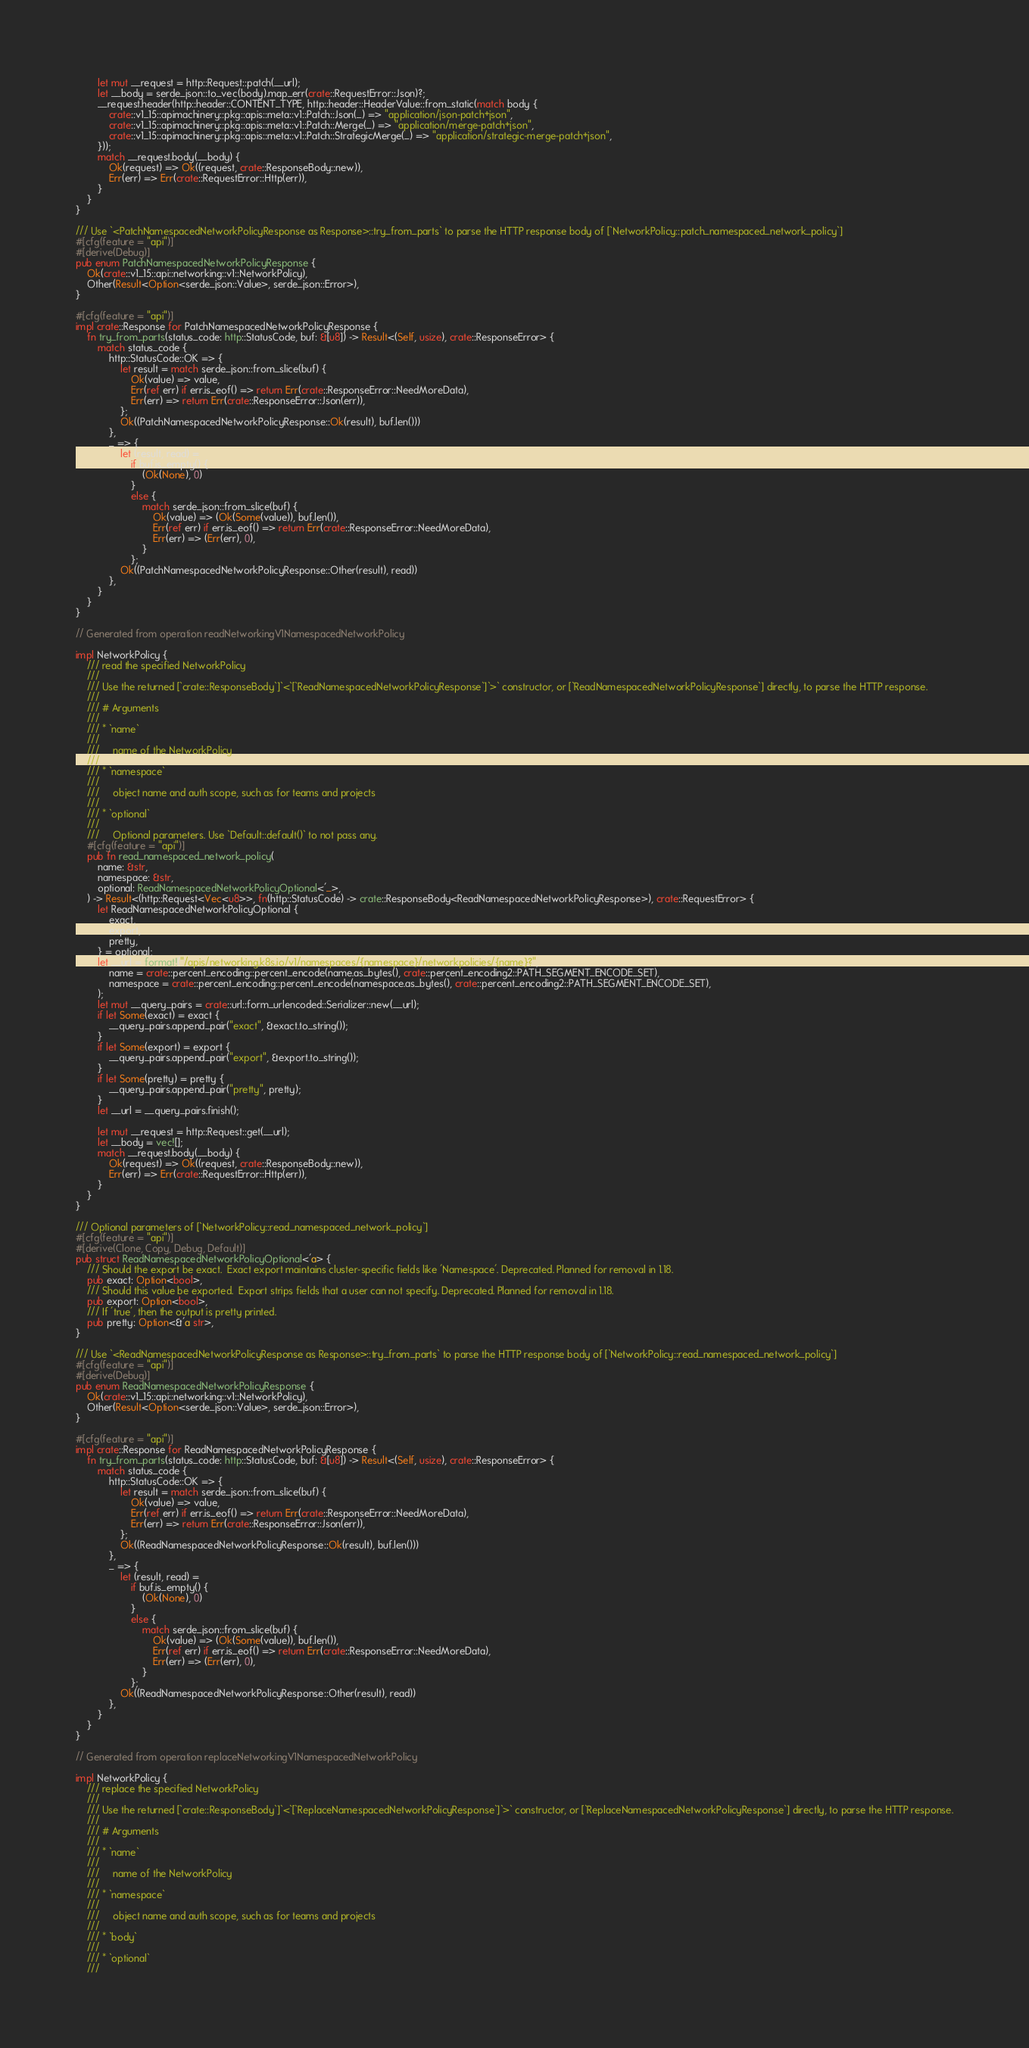Convert code to text. <code><loc_0><loc_0><loc_500><loc_500><_Rust_>        let mut __request = http::Request::patch(__url);
        let __body = serde_json::to_vec(body).map_err(crate::RequestError::Json)?;
        __request.header(http::header::CONTENT_TYPE, http::header::HeaderValue::from_static(match body {
            crate::v1_15::apimachinery::pkg::apis::meta::v1::Patch::Json(_) => "application/json-patch+json",
            crate::v1_15::apimachinery::pkg::apis::meta::v1::Patch::Merge(_) => "application/merge-patch+json",
            crate::v1_15::apimachinery::pkg::apis::meta::v1::Patch::StrategicMerge(_) => "application/strategic-merge-patch+json",
        }));
        match __request.body(__body) {
            Ok(request) => Ok((request, crate::ResponseBody::new)),
            Err(err) => Err(crate::RequestError::Http(err)),
        }
    }
}

/// Use `<PatchNamespacedNetworkPolicyResponse as Response>::try_from_parts` to parse the HTTP response body of [`NetworkPolicy::patch_namespaced_network_policy`]
#[cfg(feature = "api")]
#[derive(Debug)]
pub enum PatchNamespacedNetworkPolicyResponse {
    Ok(crate::v1_15::api::networking::v1::NetworkPolicy),
    Other(Result<Option<serde_json::Value>, serde_json::Error>),
}

#[cfg(feature = "api")]
impl crate::Response for PatchNamespacedNetworkPolicyResponse {
    fn try_from_parts(status_code: http::StatusCode, buf: &[u8]) -> Result<(Self, usize), crate::ResponseError> {
        match status_code {
            http::StatusCode::OK => {
                let result = match serde_json::from_slice(buf) {
                    Ok(value) => value,
                    Err(ref err) if err.is_eof() => return Err(crate::ResponseError::NeedMoreData),
                    Err(err) => return Err(crate::ResponseError::Json(err)),
                };
                Ok((PatchNamespacedNetworkPolicyResponse::Ok(result), buf.len()))
            },
            _ => {
                let (result, read) =
                    if buf.is_empty() {
                        (Ok(None), 0)
                    }
                    else {
                        match serde_json::from_slice(buf) {
                            Ok(value) => (Ok(Some(value)), buf.len()),
                            Err(ref err) if err.is_eof() => return Err(crate::ResponseError::NeedMoreData),
                            Err(err) => (Err(err), 0),
                        }
                    };
                Ok((PatchNamespacedNetworkPolicyResponse::Other(result), read))
            },
        }
    }
}

// Generated from operation readNetworkingV1NamespacedNetworkPolicy

impl NetworkPolicy {
    /// read the specified NetworkPolicy
    ///
    /// Use the returned [`crate::ResponseBody`]`<`[`ReadNamespacedNetworkPolicyResponse`]`>` constructor, or [`ReadNamespacedNetworkPolicyResponse`] directly, to parse the HTTP response.
    ///
    /// # Arguments
    ///
    /// * `name`
    ///
    ///     name of the NetworkPolicy
    ///
    /// * `namespace`
    ///
    ///     object name and auth scope, such as for teams and projects
    ///
    /// * `optional`
    ///
    ///     Optional parameters. Use `Default::default()` to not pass any.
    #[cfg(feature = "api")]
    pub fn read_namespaced_network_policy(
        name: &str,
        namespace: &str,
        optional: ReadNamespacedNetworkPolicyOptional<'_>,
    ) -> Result<(http::Request<Vec<u8>>, fn(http::StatusCode) -> crate::ResponseBody<ReadNamespacedNetworkPolicyResponse>), crate::RequestError> {
        let ReadNamespacedNetworkPolicyOptional {
            exact,
            export,
            pretty,
        } = optional;
        let __url = format!("/apis/networking.k8s.io/v1/namespaces/{namespace}/networkpolicies/{name}?",
            name = crate::percent_encoding::percent_encode(name.as_bytes(), crate::percent_encoding2::PATH_SEGMENT_ENCODE_SET),
            namespace = crate::percent_encoding::percent_encode(namespace.as_bytes(), crate::percent_encoding2::PATH_SEGMENT_ENCODE_SET),
        );
        let mut __query_pairs = crate::url::form_urlencoded::Serializer::new(__url);
        if let Some(exact) = exact {
            __query_pairs.append_pair("exact", &exact.to_string());
        }
        if let Some(export) = export {
            __query_pairs.append_pair("export", &export.to_string());
        }
        if let Some(pretty) = pretty {
            __query_pairs.append_pair("pretty", pretty);
        }
        let __url = __query_pairs.finish();

        let mut __request = http::Request::get(__url);
        let __body = vec![];
        match __request.body(__body) {
            Ok(request) => Ok((request, crate::ResponseBody::new)),
            Err(err) => Err(crate::RequestError::Http(err)),
        }
    }
}

/// Optional parameters of [`NetworkPolicy::read_namespaced_network_policy`]
#[cfg(feature = "api")]
#[derive(Clone, Copy, Debug, Default)]
pub struct ReadNamespacedNetworkPolicyOptional<'a> {
    /// Should the export be exact.  Exact export maintains cluster-specific fields like 'Namespace'. Deprecated. Planned for removal in 1.18.
    pub exact: Option<bool>,
    /// Should this value be exported.  Export strips fields that a user can not specify. Deprecated. Planned for removal in 1.18.
    pub export: Option<bool>,
    /// If 'true', then the output is pretty printed.
    pub pretty: Option<&'a str>,
}

/// Use `<ReadNamespacedNetworkPolicyResponse as Response>::try_from_parts` to parse the HTTP response body of [`NetworkPolicy::read_namespaced_network_policy`]
#[cfg(feature = "api")]
#[derive(Debug)]
pub enum ReadNamespacedNetworkPolicyResponse {
    Ok(crate::v1_15::api::networking::v1::NetworkPolicy),
    Other(Result<Option<serde_json::Value>, serde_json::Error>),
}

#[cfg(feature = "api")]
impl crate::Response for ReadNamespacedNetworkPolicyResponse {
    fn try_from_parts(status_code: http::StatusCode, buf: &[u8]) -> Result<(Self, usize), crate::ResponseError> {
        match status_code {
            http::StatusCode::OK => {
                let result = match serde_json::from_slice(buf) {
                    Ok(value) => value,
                    Err(ref err) if err.is_eof() => return Err(crate::ResponseError::NeedMoreData),
                    Err(err) => return Err(crate::ResponseError::Json(err)),
                };
                Ok((ReadNamespacedNetworkPolicyResponse::Ok(result), buf.len()))
            },
            _ => {
                let (result, read) =
                    if buf.is_empty() {
                        (Ok(None), 0)
                    }
                    else {
                        match serde_json::from_slice(buf) {
                            Ok(value) => (Ok(Some(value)), buf.len()),
                            Err(ref err) if err.is_eof() => return Err(crate::ResponseError::NeedMoreData),
                            Err(err) => (Err(err), 0),
                        }
                    };
                Ok((ReadNamespacedNetworkPolicyResponse::Other(result), read))
            },
        }
    }
}

// Generated from operation replaceNetworkingV1NamespacedNetworkPolicy

impl NetworkPolicy {
    /// replace the specified NetworkPolicy
    ///
    /// Use the returned [`crate::ResponseBody`]`<`[`ReplaceNamespacedNetworkPolicyResponse`]`>` constructor, or [`ReplaceNamespacedNetworkPolicyResponse`] directly, to parse the HTTP response.
    ///
    /// # Arguments
    ///
    /// * `name`
    ///
    ///     name of the NetworkPolicy
    ///
    /// * `namespace`
    ///
    ///     object name and auth scope, such as for teams and projects
    ///
    /// * `body`
    ///
    /// * `optional`
    ///</code> 